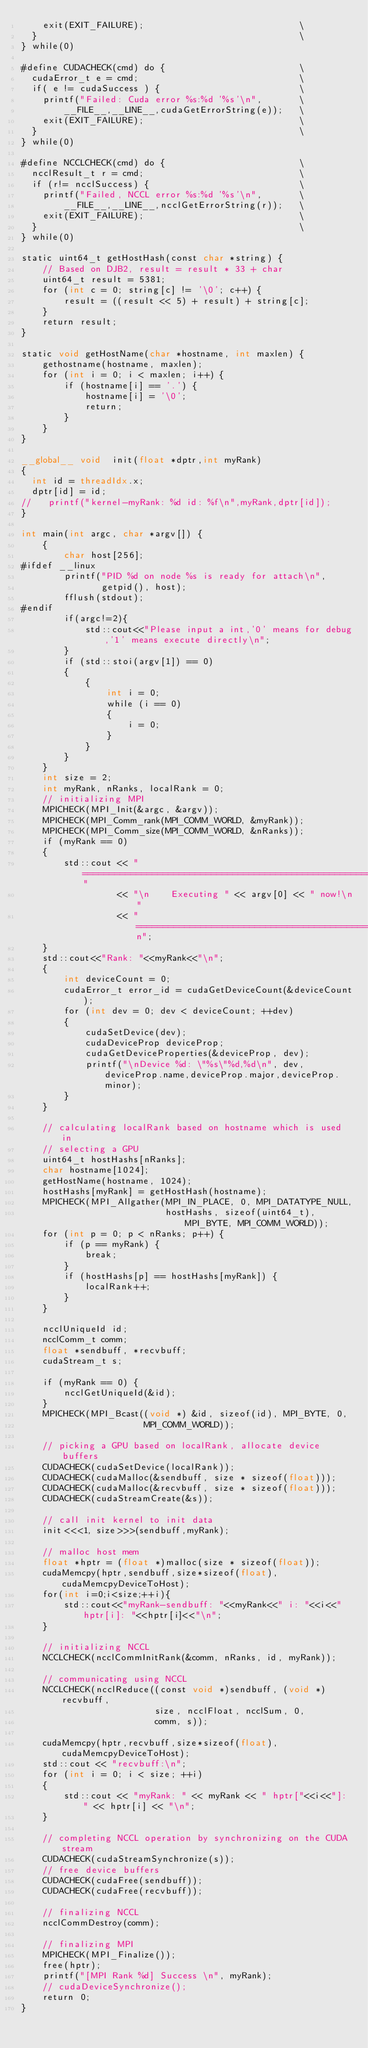Convert code to text. <code><loc_0><loc_0><loc_500><loc_500><_Cuda_>    exit(EXIT_FAILURE);                             \
  }                                                 \
} while(0)

#define CUDACHECK(cmd) do {                         \
  cudaError_t e = cmd;                              \
  if( e != cudaSuccess ) {                          \
    printf("Failed: Cuda error %s:%d '%s'\n",       \
        __FILE__,__LINE__,cudaGetErrorString(e));   \
    exit(EXIT_FAILURE);                             \
  }                                                 \
} while(0)

#define NCCLCHECK(cmd) do {                         \
  ncclResult_t r = cmd;                             \
  if (r!= ncclSuccess) {                            \
    printf("Failed, NCCL error %s:%d '%s'\n",       \
        __FILE__,__LINE__,ncclGetErrorString(r));   \
    exit(EXIT_FAILURE);                             \
  }                                                 \
} while(0)

static uint64_t getHostHash(const char *string) {
    // Based on DJB2, result = result * 33 + char
    uint64_t result = 5381;
    for (int c = 0; string[c] != '\0'; c++) {
        result = ((result << 5) + result) + string[c];
    }
    return result;
}

static void getHostName(char *hostname, int maxlen) {
    gethostname(hostname, maxlen);
    for (int i = 0; i < maxlen; i++) {
        if (hostname[i] == '.') {
            hostname[i] = '\0';
            return;
        }
    }
}

__global__ void  init(float *dptr,int myRank)
{
  int id = threadIdx.x;
  dptr[id] = id;
//   printf("kernel-myRank: %d id: %f\n",myRank,dptr[id]);
}

int main(int argc, char *argv[]) {
    {
        char host[256];
#ifdef __linux
        printf("PID %d on node %s is ready for attach\n",
               getpid(), host);
        fflush(stdout);
#endif
        if(argc!=2){
            std::cout<<"Please input a int,'0' means for debug,'1' means execute directly\n";
        }
        if (std::stoi(argv[1]) == 0)
        {
            {
                int i = 0;
                while (i == 0)
                {
                    i = 0;
                }
            }
        }
    }
    int size = 2;
    int myRank, nRanks, localRank = 0;
    // initializing MPI
    MPICHECK(MPI_Init(&argc, &argv));
    MPICHECK(MPI_Comm_rank(MPI_COMM_WORLD, &myRank));
    MPICHECK(MPI_Comm_size(MPI_COMM_WORLD, &nRanks));
    if (myRank == 0)
    {
        std::cout << "================================================================"
                  << "\n    Executing " << argv[0] << " now!\n"
                  << "================================================================\n";
    }
    std::cout<<"Rank: "<<myRank<<"\n";
    {
        int deviceCount = 0;
        cudaError_t error_id = cudaGetDeviceCount(&deviceCount);
        for (int dev = 0; dev < deviceCount; ++dev)
        {
            cudaSetDevice(dev);
            cudaDeviceProp deviceProp;
            cudaGetDeviceProperties(&deviceProp, dev);
            printf("\nDevice %d: \"%s\"%d,%d\n", dev, deviceProp.name,deviceProp.major,deviceProp.minor);
        }
    }

    // calculating localRank based on hostname which is used in
    // selecting a GPU
    uint64_t hostHashs[nRanks];
    char hostname[1024];
    getHostName(hostname, 1024);
    hostHashs[myRank] = getHostHash(hostname);
    MPICHECK(MPI_Allgather(MPI_IN_PLACE, 0, MPI_DATATYPE_NULL,
                           hostHashs, sizeof(uint64_t), MPI_BYTE, MPI_COMM_WORLD));
    for (int p = 0; p < nRanks; p++) {
        if (p == myRank) {
            break;
        }
        if (hostHashs[p] == hostHashs[myRank]) {
            localRank++;
        }
    }

    ncclUniqueId id;
    ncclComm_t comm;
    float *sendbuff, *recvbuff;
    cudaStream_t s;

    if (myRank == 0) {
        ncclGetUniqueId(&id);
    }
    MPICHECK(MPI_Bcast((void *) &id, sizeof(id), MPI_BYTE, 0,
                       MPI_COMM_WORLD));

    // picking a GPU based on localRank, allocate device buffers
    CUDACHECK(cudaSetDevice(localRank));
    CUDACHECK(cudaMalloc(&sendbuff, size * sizeof(float)));
    CUDACHECK(cudaMalloc(&recvbuff, size * sizeof(float)));
    CUDACHECK(cudaStreamCreate(&s));

    // call init kernel to init data
    init<<<1, size>>>(sendbuff,myRank);

    // malloc host mem
    float *hptr = (float *)malloc(size * sizeof(float));
    cudaMemcpy(hptr,sendbuff,size*sizeof(float),cudaMemcpyDeviceToHost);
    for(int i=0;i<size;++i){
        std::cout<<"myRank-sendbuff: "<<myRank<<" i: "<<i<<" hptr[i]: "<<hptr[i]<<"\n";
    }

    // initializing NCCL
    NCCLCHECK(ncclCommInitRank(&comm, nRanks, id, myRank));

    // communicating using NCCL
    NCCLCHECK(ncclReduce((const void *)sendbuff, (void *)recvbuff,
                         size, ncclFloat, ncclSum, 0,
                         comm, s));
                         
    cudaMemcpy(hptr,recvbuff,size*sizeof(float),cudaMemcpyDeviceToHost);
    std::cout << "recvbuff:\n";
    for (int i = 0; i < size; ++i)
    {
        std::cout << "myRank: " << myRank << " hptr["<<i<<"]: " << hptr[i] << "\n";
    }

    // completing NCCL operation by synchronizing on the CUDA stream
    CUDACHECK(cudaStreamSynchronize(s));
    // free device buffers
    CUDACHECK(cudaFree(sendbuff));
    CUDACHECK(cudaFree(recvbuff));

    // finalizing NCCL
    ncclCommDestroy(comm);

    // finalizing MPI
    MPICHECK(MPI_Finalize());
    free(hptr);
    printf("[MPI Rank %d] Success \n", myRank);
    // cudaDeviceSynchronize();
    return 0;
}</code> 